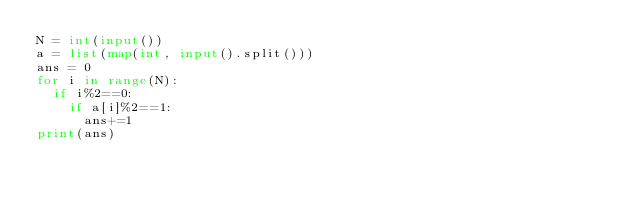<code> <loc_0><loc_0><loc_500><loc_500><_Python_>N = int(input())
a = list(map(int, input().split()))
ans = 0
for i in range(N):
  if i%2==0:
    if a[i]%2==1:
      ans+=1
print(ans)</code> 